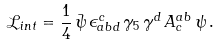Convert formula to latex. <formula><loc_0><loc_0><loc_500><loc_500>\mathcal { L } _ { i n t } = \frac { 1 } { 4 } \, \bar { \psi } \, \epsilon ^ { c } _ { a b d } \, \gamma _ { 5 } \, \gamma ^ { d } \, A ^ { a b } _ { c } \, \psi \, .</formula> 